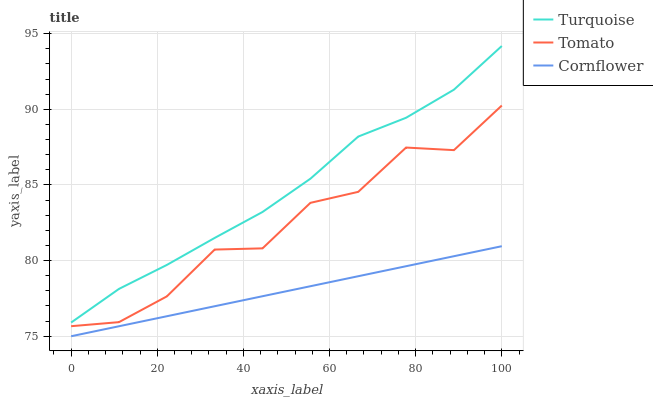Does Cornflower have the minimum area under the curve?
Answer yes or no. Yes. Does Turquoise have the maximum area under the curve?
Answer yes or no. Yes. Does Turquoise have the minimum area under the curve?
Answer yes or no. No. Does Cornflower have the maximum area under the curve?
Answer yes or no. No. Is Cornflower the smoothest?
Answer yes or no. Yes. Is Tomato the roughest?
Answer yes or no. Yes. Is Turquoise the smoothest?
Answer yes or no. No. Is Turquoise the roughest?
Answer yes or no. No. Does Cornflower have the lowest value?
Answer yes or no. Yes. Does Turquoise have the lowest value?
Answer yes or no. No. Does Turquoise have the highest value?
Answer yes or no. Yes. Does Cornflower have the highest value?
Answer yes or no. No. Is Tomato less than Turquoise?
Answer yes or no. Yes. Is Turquoise greater than Cornflower?
Answer yes or no. Yes. Does Tomato intersect Turquoise?
Answer yes or no. No. 